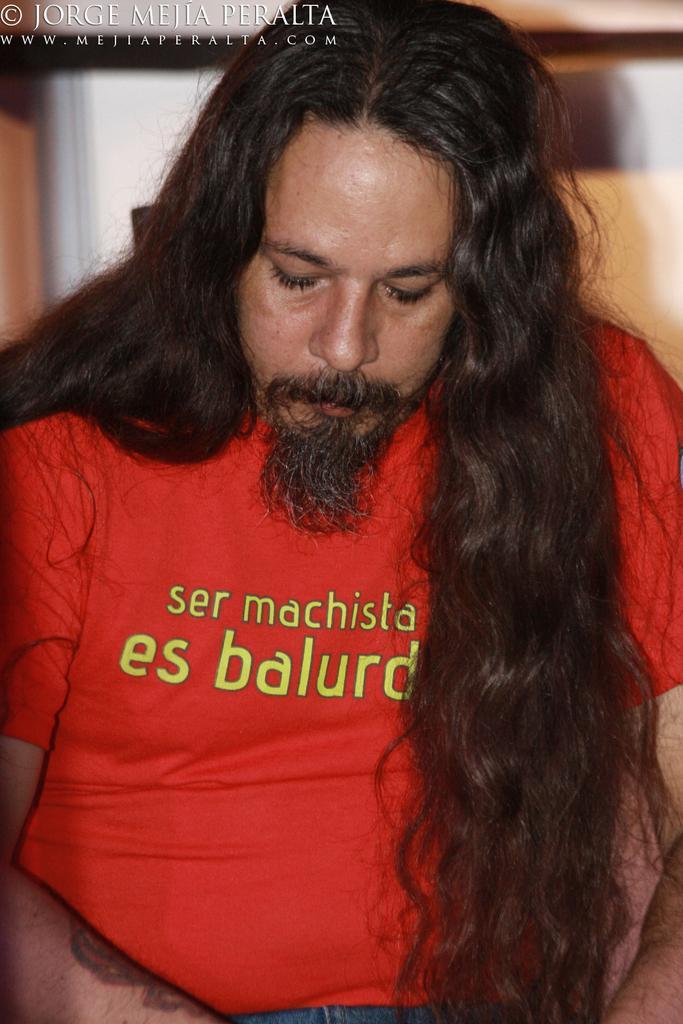Describe this image in one or two sentences. In this image we can see a person wearing red t shirt with long hair. In the background we can see some text. 